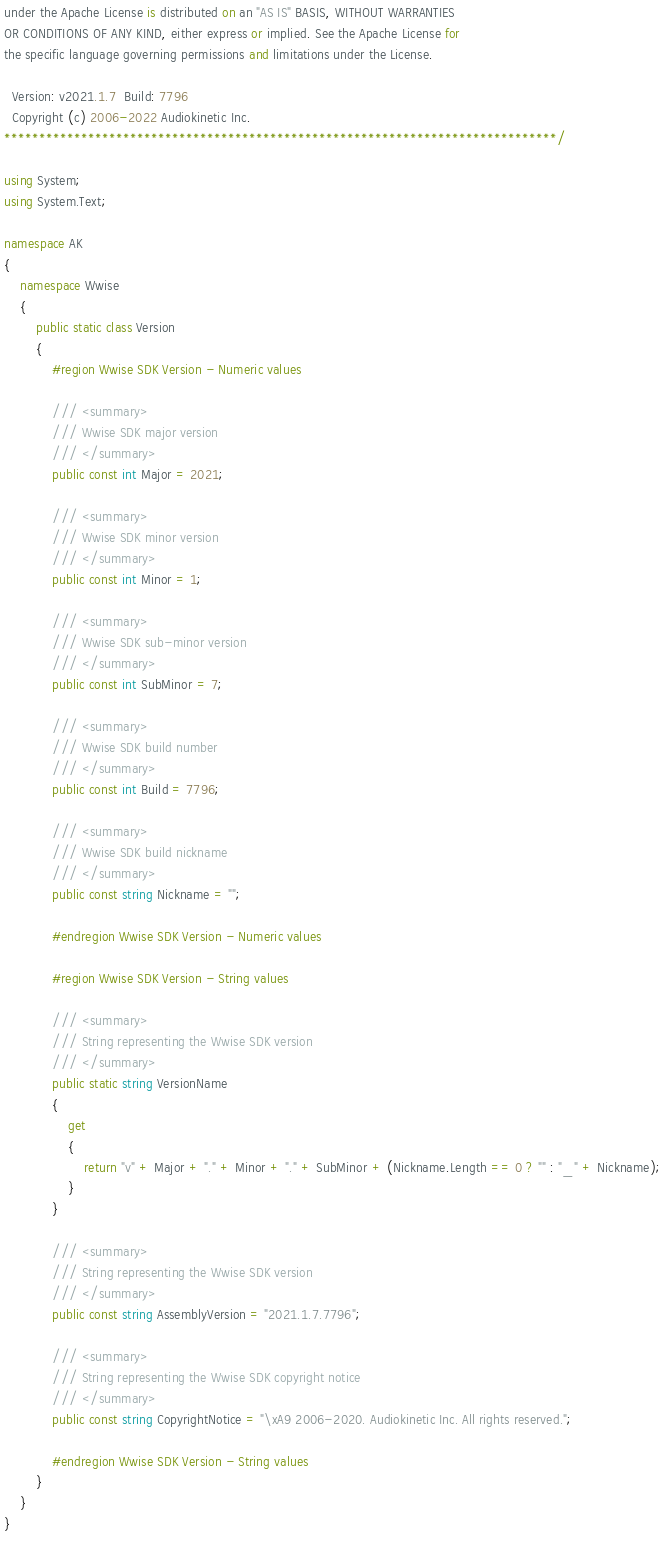<code> <loc_0><loc_0><loc_500><loc_500><_C#_>under the Apache License is distributed on an "AS IS" BASIS, WITHOUT WARRANTIES
OR CONDITIONS OF ANY KIND, either express or implied. See the Apache License for
the specific language governing permissions and limitations under the License.

  Version: v2021.1.7  Build: 7796
  Copyright (c) 2006-2022 Audiokinetic Inc.
*******************************************************************************/

using System;
using System.Text;

namespace AK
{
	namespace Wwise
	{
		public static class Version
		{
			#region Wwise SDK Version - Numeric values

			/// <summary>
			/// Wwise SDK major version
			/// </summary>
            public const int Major = 2021;

			/// <summary>
			/// Wwise SDK minor version
			/// </summary>
            public const int Minor = 1;

			/// <summary>
			/// Wwise SDK sub-minor version
			/// </summary>
            public const int SubMinor = 7;

			/// <summary>
			/// Wwise SDK build number
			/// </summary>
            public const int Build = 7796;

			/// <summary>
			/// Wwise SDK build nickname
			/// </summary>
			public const string Nickname = "";

			#endregion Wwise SDK Version - Numeric values

			#region Wwise SDK Version - String values

			/// <summary>
			/// String representing the Wwise SDK version
			/// </summary>
            public static string VersionName
            {
                get
                {
                    return "v" + Major + "." + Minor + "." + SubMinor + (Nickname.Length == 0 ? "" : "_" + Nickname);
                }
            }

            /// <summary>
            /// String representing the Wwise SDK version
            /// </summary>
            public const string AssemblyVersion = "2021.1.7.7796";

			/// <summary>
			/// String representing the Wwise SDK copyright notice
			/// </summary>
            public const string CopyrightNotice = "\xA9 2006-2020. Audiokinetic Inc. All rights reserved.";

            #endregion Wwise SDK Version - String values
        }
	}
}
</code> 